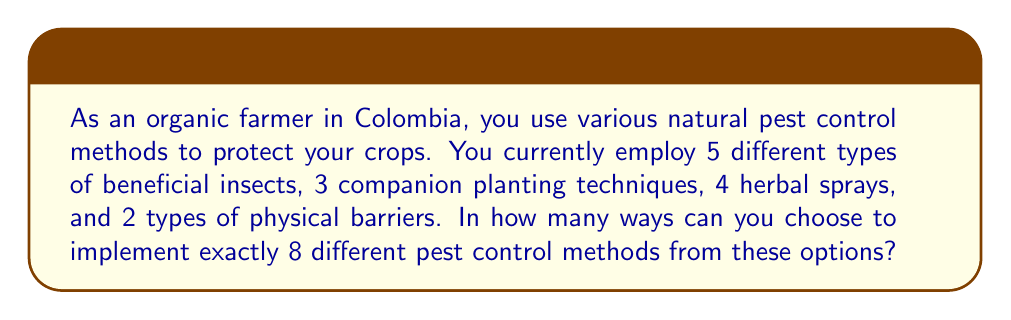Teach me how to tackle this problem. Let's approach this step-by-step using the combination formula:

1) We have four categories of pest control methods:
   - Beneficial insects: 5 options
   - Companion planting: 3 options
   - Herbal sprays: 4 options
   - Physical barriers: 2 options

2) We need to choose 8 methods in total from these categories. This is a combination problem where order doesn't matter.

3) We can use the combination formula:

   $${n \choose k} = \frac{n!}{k!(n-k)!}$$

   Where $n$ is the total number of options (5 + 3 + 4 + 2 = 14) and $k$ is the number we're choosing (8).

4) Plugging in the numbers:

   $$\binom{14}{8} = \frac{14!}{8!(14-8)!} = \frac{14!}{8!6!}$$

5) Calculating this:
   
   $$\frac{14 * 13 * 12 * 11 * 10 * 9 * 8!}{8! * 6 * 5 * 4 * 3 * 2 * 1} = 3003$$

Therefore, there are 3003 different ways to choose 8 pest control methods from the available options.
Answer: 3003 